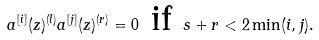Convert formula to latex. <formula><loc_0><loc_0><loc_500><loc_500>a ^ { [ i ] } ( z ) ^ { ( l ) } a ^ { [ j ] } ( z ) ^ { ( r ) } = 0 \text { if } s + r < 2 \min ( i , j ) .</formula> 